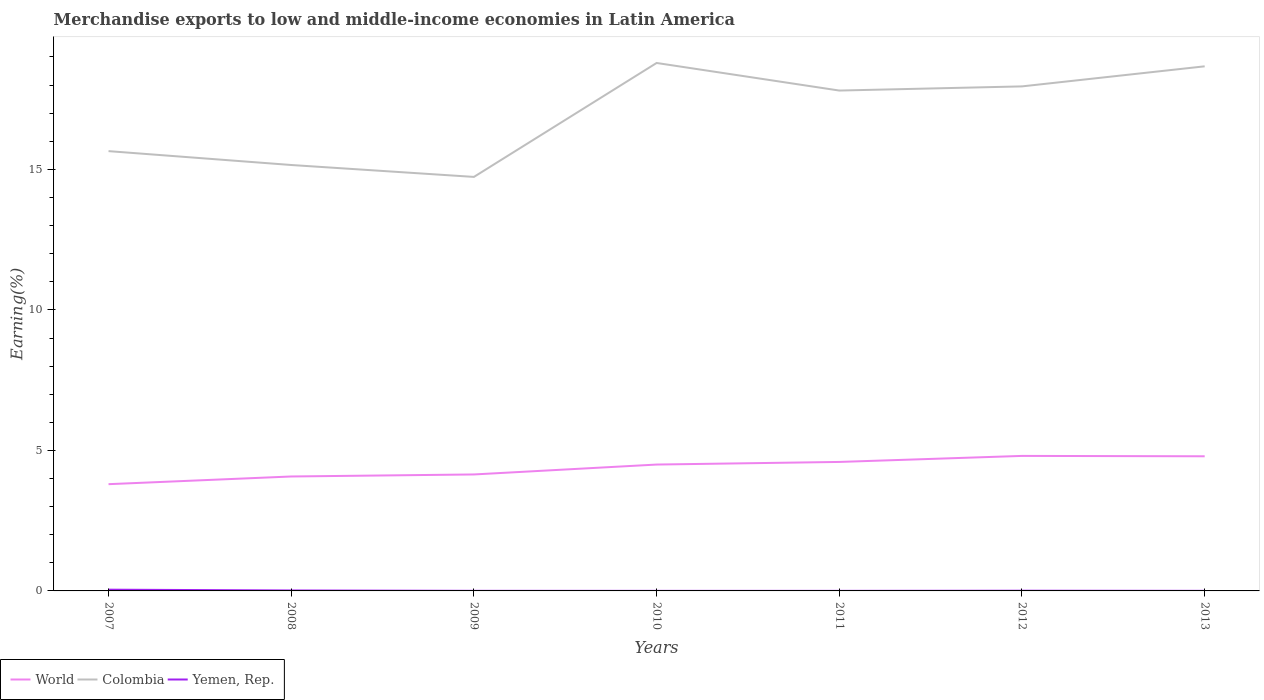Across all years, what is the maximum percentage of amount earned from merchandise exports in Yemen, Rep.?
Offer a very short reply. 0. What is the total percentage of amount earned from merchandise exports in Yemen, Rep. in the graph?
Your answer should be very brief. 0. What is the difference between the highest and the second highest percentage of amount earned from merchandise exports in World?
Your answer should be very brief. 1.01. What is the difference between the highest and the lowest percentage of amount earned from merchandise exports in World?
Make the answer very short. 4. Is the percentage of amount earned from merchandise exports in World strictly greater than the percentage of amount earned from merchandise exports in Colombia over the years?
Ensure brevity in your answer.  Yes. How many years are there in the graph?
Make the answer very short. 7. What is the difference between two consecutive major ticks on the Y-axis?
Offer a very short reply. 5. Does the graph contain any zero values?
Keep it short and to the point. No. How many legend labels are there?
Offer a very short reply. 3. How are the legend labels stacked?
Offer a terse response. Horizontal. What is the title of the graph?
Your answer should be compact. Merchandise exports to low and middle-income economies in Latin America. What is the label or title of the X-axis?
Keep it short and to the point. Years. What is the label or title of the Y-axis?
Your answer should be compact. Earning(%). What is the Earning(%) of World in 2007?
Give a very brief answer. 3.8. What is the Earning(%) of Colombia in 2007?
Provide a succinct answer. 15.65. What is the Earning(%) of Yemen, Rep. in 2007?
Offer a terse response. 0.04. What is the Earning(%) in World in 2008?
Keep it short and to the point. 4.07. What is the Earning(%) in Colombia in 2008?
Provide a short and direct response. 15.16. What is the Earning(%) of Yemen, Rep. in 2008?
Offer a very short reply. 0.02. What is the Earning(%) in World in 2009?
Offer a very short reply. 4.14. What is the Earning(%) of Colombia in 2009?
Provide a short and direct response. 14.73. What is the Earning(%) in Yemen, Rep. in 2009?
Provide a succinct answer. 0. What is the Earning(%) of World in 2010?
Make the answer very short. 4.5. What is the Earning(%) in Colombia in 2010?
Provide a short and direct response. 18.79. What is the Earning(%) of Yemen, Rep. in 2010?
Your answer should be very brief. 0. What is the Earning(%) in World in 2011?
Provide a succinct answer. 4.59. What is the Earning(%) in Colombia in 2011?
Your answer should be very brief. 17.81. What is the Earning(%) of Yemen, Rep. in 2011?
Ensure brevity in your answer.  0. What is the Earning(%) of World in 2012?
Your answer should be compact. 4.8. What is the Earning(%) in Colombia in 2012?
Keep it short and to the point. 17.95. What is the Earning(%) in Yemen, Rep. in 2012?
Offer a terse response. 0.01. What is the Earning(%) in World in 2013?
Your response must be concise. 4.79. What is the Earning(%) of Colombia in 2013?
Ensure brevity in your answer.  18.67. What is the Earning(%) in Yemen, Rep. in 2013?
Keep it short and to the point. 0. Across all years, what is the maximum Earning(%) in World?
Make the answer very short. 4.8. Across all years, what is the maximum Earning(%) in Colombia?
Ensure brevity in your answer.  18.79. Across all years, what is the maximum Earning(%) of Yemen, Rep.?
Your answer should be compact. 0.04. Across all years, what is the minimum Earning(%) of World?
Offer a terse response. 3.8. Across all years, what is the minimum Earning(%) in Colombia?
Your answer should be very brief. 14.73. Across all years, what is the minimum Earning(%) of Yemen, Rep.?
Provide a short and direct response. 0. What is the total Earning(%) in World in the graph?
Offer a very short reply. 30.7. What is the total Earning(%) of Colombia in the graph?
Provide a succinct answer. 118.76. What is the total Earning(%) of Yemen, Rep. in the graph?
Provide a succinct answer. 0.08. What is the difference between the Earning(%) of World in 2007 and that in 2008?
Offer a very short reply. -0.27. What is the difference between the Earning(%) in Colombia in 2007 and that in 2008?
Give a very brief answer. 0.49. What is the difference between the Earning(%) in Yemen, Rep. in 2007 and that in 2008?
Ensure brevity in your answer.  0.03. What is the difference between the Earning(%) of World in 2007 and that in 2009?
Ensure brevity in your answer.  -0.35. What is the difference between the Earning(%) of Colombia in 2007 and that in 2009?
Give a very brief answer. 0.92. What is the difference between the Earning(%) of Yemen, Rep. in 2007 and that in 2009?
Your response must be concise. 0.04. What is the difference between the Earning(%) in World in 2007 and that in 2010?
Your answer should be compact. -0.7. What is the difference between the Earning(%) of Colombia in 2007 and that in 2010?
Ensure brevity in your answer.  -3.14. What is the difference between the Earning(%) in Yemen, Rep. in 2007 and that in 2010?
Your answer should be compact. 0.04. What is the difference between the Earning(%) of World in 2007 and that in 2011?
Ensure brevity in your answer.  -0.79. What is the difference between the Earning(%) in Colombia in 2007 and that in 2011?
Your answer should be compact. -2.16. What is the difference between the Earning(%) in Yemen, Rep. in 2007 and that in 2011?
Your answer should be compact. 0.04. What is the difference between the Earning(%) of World in 2007 and that in 2012?
Your response must be concise. -1.01. What is the difference between the Earning(%) in Colombia in 2007 and that in 2012?
Provide a succinct answer. -2.3. What is the difference between the Earning(%) of Yemen, Rep. in 2007 and that in 2012?
Your answer should be compact. 0.04. What is the difference between the Earning(%) of World in 2007 and that in 2013?
Make the answer very short. -0.99. What is the difference between the Earning(%) of Colombia in 2007 and that in 2013?
Your answer should be very brief. -3.02. What is the difference between the Earning(%) of Yemen, Rep. in 2007 and that in 2013?
Provide a succinct answer. 0.04. What is the difference between the Earning(%) in World in 2008 and that in 2009?
Your answer should be very brief. -0.07. What is the difference between the Earning(%) in Colombia in 2008 and that in 2009?
Make the answer very short. 0.42. What is the difference between the Earning(%) in Yemen, Rep. in 2008 and that in 2009?
Provide a succinct answer. 0.01. What is the difference between the Earning(%) of World in 2008 and that in 2010?
Offer a terse response. -0.42. What is the difference between the Earning(%) of Colombia in 2008 and that in 2010?
Your answer should be compact. -3.63. What is the difference between the Earning(%) of Yemen, Rep. in 2008 and that in 2010?
Give a very brief answer. 0.01. What is the difference between the Earning(%) of World in 2008 and that in 2011?
Keep it short and to the point. -0.52. What is the difference between the Earning(%) of Colombia in 2008 and that in 2011?
Provide a short and direct response. -2.65. What is the difference between the Earning(%) in Yemen, Rep. in 2008 and that in 2011?
Your response must be concise. 0.01. What is the difference between the Earning(%) of World in 2008 and that in 2012?
Make the answer very short. -0.73. What is the difference between the Earning(%) in Colombia in 2008 and that in 2012?
Offer a terse response. -2.8. What is the difference between the Earning(%) in Yemen, Rep. in 2008 and that in 2012?
Offer a terse response. 0.01. What is the difference between the Earning(%) of World in 2008 and that in 2013?
Your answer should be very brief. -0.72. What is the difference between the Earning(%) of Colombia in 2008 and that in 2013?
Give a very brief answer. -3.51. What is the difference between the Earning(%) of Yemen, Rep. in 2008 and that in 2013?
Provide a short and direct response. 0.01. What is the difference between the Earning(%) of World in 2009 and that in 2010?
Provide a succinct answer. -0.35. What is the difference between the Earning(%) of Colombia in 2009 and that in 2010?
Your answer should be compact. -4.05. What is the difference between the Earning(%) of Yemen, Rep. in 2009 and that in 2010?
Your answer should be compact. 0. What is the difference between the Earning(%) of World in 2009 and that in 2011?
Give a very brief answer. -0.45. What is the difference between the Earning(%) in Colombia in 2009 and that in 2011?
Offer a terse response. -3.07. What is the difference between the Earning(%) of Yemen, Rep. in 2009 and that in 2011?
Your answer should be very brief. 0. What is the difference between the Earning(%) in World in 2009 and that in 2012?
Your response must be concise. -0.66. What is the difference between the Earning(%) of Colombia in 2009 and that in 2012?
Keep it short and to the point. -3.22. What is the difference between the Earning(%) in Yemen, Rep. in 2009 and that in 2012?
Offer a very short reply. -0. What is the difference between the Earning(%) in World in 2009 and that in 2013?
Give a very brief answer. -0.65. What is the difference between the Earning(%) of Colombia in 2009 and that in 2013?
Offer a terse response. -3.94. What is the difference between the Earning(%) in World in 2010 and that in 2011?
Your answer should be very brief. -0.09. What is the difference between the Earning(%) in Colombia in 2010 and that in 2011?
Ensure brevity in your answer.  0.98. What is the difference between the Earning(%) of World in 2010 and that in 2012?
Provide a succinct answer. -0.31. What is the difference between the Earning(%) of Colombia in 2010 and that in 2012?
Your response must be concise. 0.83. What is the difference between the Earning(%) in Yemen, Rep. in 2010 and that in 2012?
Give a very brief answer. -0.01. What is the difference between the Earning(%) of World in 2010 and that in 2013?
Offer a very short reply. -0.29. What is the difference between the Earning(%) of Colombia in 2010 and that in 2013?
Give a very brief answer. 0.12. What is the difference between the Earning(%) in Yemen, Rep. in 2010 and that in 2013?
Your answer should be compact. -0. What is the difference between the Earning(%) of World in 2011 and that in 2012?
Make the answer very short. -0.21. What is the difference between the Earning(%) of Colombia in 2011 and that in 2012?
Your answer should be compact. -0.15. What is the difference between the Earning(%) of Yemen, Rep. in 2011 and that in 2012?
Offer a very short reply. -0.01. What is the difference between the Earning(%) of World in 2011 and that in 2013?
Provide a short and direct response. -0.2. What is the difference between the Earning(%) in Colombia in 2011 and that in 2013?
Keep it short and to the point. -0.86. What is the difference between the Earning(%) of Yemen, Rep. in 2011 and that in 2013?
Provide a succinct answer. -0. What is the difference between the Earning(%) of World in 2012 and that in 2013?
Offer a very short reply. 0.01. What is the difference between the Earning(%) in Colombia in 2012 and that in 2013?
Offer a terse response. -0.71. What is the difference between the Earning(%) in Yemen, Rep. in 2012 and that in 2013?
Give a very brief answer. 0. What is the difference between the Earning(%) in World in 2007 and the Earning(%) in Colombia in 2008?
Your answer should be compact. -11.36. What is the difference between the Earning(%) in World in 2007 and the Earning(%) in Yemen, Rep. in 2008?
Provide a short and direct response. 3.78. What is the difference between the Earning(%) in Colombia in 2007 and the Earning(%) in Yemen, Rep. in 2008?
Your response must be concise. 15.63. What is the difference between the Earning(%) of World in 2007 and the Earning(%) of Colombia in 2009?
Your answer should be very brief. -10.93. What is the difference between the Earning(%) of World in 2007 and the Earning(%) of Yemen, Rep. in 2009?
Provide a short and direct response. 3.8. What is the difference between the Earning(%) of Colombia in 2007 and the Earning(%) of Yemen, Rep. in 2009?
Provide a short and direct response. 15.65. What is the difference between the Earning(%) of World in 2007 and the Earning(%) of Colombia in 2010?
Keep it short and to the point. -14.99. What is the difference between the Earning(%) of World in 2007 and the Earning(%) of Yemen, Rep. in 2010?
Offer a terse response. 3.8. What is the difference between the Earning(%) in Colombia in 2007 and the Earning(%) in Yemen, Rep. in 2010?
Keep it short and to the point. 15.65. What is the difference between the Earning(%) of World in 2007 and the Earning(%) of Colombia in 2011?
Make the answer very short. -14.01. What is the difference between the Earning(%) of World in 2007 and the Earning(%) of Yemen, Rep. in 2011?
Your answer should be very brief. 3.8. What is the difference between the Earning(%) in Colombia in 2007 and the Earning(%) in Yemen, Rep. in 2011?
Provide a succinct answer. 15.65. What is the difference between the Earning(%) in World in 2007 and the Earning(%) in Colombia in 2012?
Ensure brevity in your answer.  -14.16. What is the difference between the Earning(%) in World in 2007 and the Earning(%) in Yemen, Rep. in 2012?
Your answer should be very brief. 3.79. What is the difference between the Earning(%) of Colombia in 2007 and the Earning(%) of Yemen, Rep. in 2012?
Your response must be concise. 15.64. What is the difference between the Earning(%) in World in 2007 and the Earning(%) in Colombia in 2013?
Offer a very short reply. -14.87. What is the difference between the Earning(%) in World in 2007 and the Earning(%) in Yemen, Rep. in 2013?
Your answer should be compact. 3.8. What is the difference between the Earning(%) of Colombia in 2007 and the Earning(%) of Yemen, Rep. in 2013?
Offer a terse response. 15.65. What is the difference between the Earning(%) of World in 2008 and the Earning(%) of Colombia in 2009?
Give a very brief answer. -10.66. What is the difference between the Earning(%) in World in 2008 and the Earning(%) in Yemen, Rep. in 2009?
Your answer should be compact. 4.07. What is the difference between the Earning(%) of Colombia in 2008 and the Earning(%) of Yemen, Rep. in 2009?
Give a very brief answer. 15.15. What is the difference between the Earning(%) of World in 2008 and the Earning(%) of Colombia in 2010?
Your response must be concise. -14.72. What is the difference between the Earning(%) in World in 2008 and the Earning(%) in Yemen, Rep. in 2010?
Your answer should be very brief. 4.07. What is the difference between the Earning(%) in Colombia in 2008 and the Earning(%) in Yemen, Rep. in 2010?
Offer a very short reply. 15.15. What is the difference between the Earning(%) in World in 2008 and the Earning(%) in Colombia in 2011?
Keep it short and to the point. -13.73. What is the difference between the Earning(%) in World in 2008 and the Earning(%) in Yemen, Rep. in 2011?
Your response must be concise. 4.07. What is the difference between the Earning(%) of Colombia in 2008 and the Earning(%) of Yemen, Rep. in 2011?
Your answer should be very brief. 15.15. What is the difference between the Earning(%) of World in 2008 and the Earning(%) of Colombia in 2012?
Ensure brevity in your answer.  -13.88. What is the difference between the Earning(%) of World in 2008 and the Earning(%) of Yemen, Rep. in 2012?
Your response must be concise. 4.06. What is the difference between the Earning(%) of Colombia in 2008 and the Earning(%) of Yemen, Rep. in 2012?
Your answer should be compact. 15.15. What is the difference between the Earning(%) in World in 2008 and the Earning(%) in Colombia in 2013?
Offer a very short reply. -14.6. What is the difference between the Earning(%) in World in 2008 and the Earning(%) in Yemen, Rep. in 2013?
Make the answer very short. 4.07. What is the difference between the Earning(%) in Colombia in 2008 and the Earning(%) in Yemen, Rep. in 2013?
Keep it short and to the point. 15.15. What is the difference between the Earning(%) in World in 2009 and the Earning(%) in Colombia in 2010?
Ensure brevity in your answer.  -14.64. What is the difference between the Earning(%) in World in 2009 and the Earning(%) in Yemen, Rep. in 2010?
Make the answer very short. 4.14. What is the difference between the Earning(%) in Colombia in 2009 and the Earning(%) in Yemen, Rep. in 2010?
Your answer should be compact. 14.73. What is the difference between the Earning(%) in World in 2009 and the Earning(%) in Colombia in 2011?
Provide a succinct answer. -13.66. What is the difference between the Earning(%) of World in 2009 and the Earning(%) of Yemen, Rep. in 2011?
Your answer should be very brief. 4.14. What is the difference between the Earning(%) of Colombia in 2009 and the Earning(%) of Yemen, Rep. in 2011?
Your response must be concise. 14.73. What is the difference between the Earning(%) in World in 2009 and the Earning(%) in Colombia in 2012?
Offer a very short reply. -13.81. What is the difference between the Earning(%) of World in 2009 and the Earning(%) of Yemen, Rep. in 2012?
Offer a terse response. 4.14. What is the difference between the Earning(%) in Colombia in 2009 and the Earning(%) in Yemen, Rep. in 2012?
Your response must be concise. 14.73. What is the difference between the Earning(%) in World in 2009 and the Earning(%) in Colombia in 2013?
Ensure brevity in your answer.  -14.52. What is the difference between the Earning(%) in World in 2009 and the Earning(%) in Yemen, Rep. in 2013?
Keep it short and to the point. 4.14. What is the difference between the Earning(%) in Colombia in 2009 and the Earning(%) in Yemen, Rep. in 2013?
Ensure brevity in your answer.  14.73. What is the difference between the Earning(%) in World in 2010 and the Earning(%) in Colombia in 2011?
Your response must be concise. -13.31. What is the difference between the Earning(%) in World in 2010 and the Earning(%) in Yemen, Rep. in 2011?
Your response must be concise. 4.49. What is the difference between the Earning(%) of Colombia in 2010 and the Earning(%) of Yemen, Rep. in 2011?
Offer a very short reply. 18.79. What is the difference between the Earning(%) of World in 2010 and the Earning(%) of Colombia in 2012?
Provide a short and direct response. -13.46. What is the difference between the Earning(%) of World in 2010 and the Earning(%) of Yemen, Rep. in 2012?
Your response must be concise. 4.49. What is the difference between the Earning(%) in Colombia in 2010 and the Earning(%) in Yemen, Rep. in 2012?
Offer a very short reply. 18.78. What is the difference between the Earning(%) in World in 2010 and the Earning(%) in Colombia in 2013?
Make the answer very short. -14.17. What is the difference between the Earning(%) of World in 2010 and the Earning(%) of Yemen, Rep. in 2013?
Provide a succinct answer. 4.49. What is the difference between the Earning(%) in Colombia in 2010 and the Earning(%) in Yemen, Rep. in 2013?
Offer a terse response. 18.78. What is the difference between the Earning(%) in World in 2011 and the Earning(%) in Colombia in 2012?
Provide a succinct answer. -13.36. What is the difference between the Earning(%) of World in 2011 and the Earning(%) of Yemen, Rep. in 2012?
Provide a short and direct response. 4.58. What is the difference between the Earning(%) in Colombia in 2011 and the Earning(%) in Yemen, Rep. in 2012?
Ensure brevity in your answer.  17.8. What is the difference between the Earning(%) in World in 2011 and the Earning(%) in Colombia in 2013?
Your answer should be compact. -14.08. What is the difference between the Earning(%) in World in 2011 and the Earning(%) in Yemen, Rep. in 2013?
Make the answer very short. 4.59. What is the difference between the Earning(%) in Colombia in 2011 and the Earning(%) in Yemen, Rep. in 2013?
Offer a terse response. 17.8. What is the difference between the Earning(%) of World in 2012 and the Earning(%) of Colombia in 2013?
Keep it short and to the point. -13.86. What is the difference between the Earning(%) of World in 2012 and the Earning(%) of Yemen, Rep. in 2013?
Provide a succinct answer. 4.8. What is the difference between the Earning(%) in Colombia in 2012 and the Earning(%) in Yemen, Rep. in 2013?
Give a very brief answer. 17.95. What is the average Earning(%) in World per year?
Offer a terse response. 4.39. What is the average Earning(%) in Colombia per year?
Give a very brief answer. 16.97. What is the average Earning(%) of Yemen, Rep. per year?
Your response must be concise. 0.01. In the year 2007, what is the difference between the Earning(%) of World and Earning(%) of Colombia?
Provide a short and direct response. -11.85. In the year 2007, what is the difference between the Earning(%) of World and Earning(%) of Yemen, Rep.?
Your answer should be very brief. 3.75. In the year 2007, what is the difference between the Earning(%) of Colombia and Earning(%) of Yemen, Rep.?
Offer a terse response. 15.61. In the year 2008, what is the difference between the Earning(%) of World and Earning(%) of Colombia?
Keep it short and to the point. -11.08. In the year 2008, what is the difference between the Earning(%) in World and Earning(%) in Yemen, Rep.?
Make the answer very short. 4.06. In the year 2008, what is the difference between the Earning(%) of Colombia and Earning(%) of Yemen, Rep.?
Make the answer very short. 15.14. In the year 2009, what is the difference between the Earning(%) in World and Earning(%) in Colombia?
Give a very brief answer. -10.59. In the year 2009, what is the difference between the Earning(%) of World and Earning(%) of Yemen, Rep.?
Your answer should be very brief. 4.14. In the year 2009, what is the difference between the Earning(%) of Colombia and Earning(%) of Yemen, Rep.?
Offer a terse response. 14.73. In the year 2010, what is the difference between the Earning(%) in World and Earning(%) in Colombia?
Provide a short and direct response. -14.29. In the year 2010, what is the difference between the Earning(%) of World and Earning(%) of Yemen, Rep.?
Provide a succinct answer. 4.49. In the year 2010, what is the difference between the Earning(%) of Colombia and Earning(%) of Yemen, Rep.?
Your answer should be compact. 18.79. In the year 2011, what is the difference between the Earning(%) of World and Earning(%) of Colombia?
Your answer should be very brief. -13.22. In the year 2011, what is the difference between the Earning(%) of World and Earning(%) of Yemen, Rep.?
Make the answer very short. 4.59. In the year 2011, what is the difference between the Earning(%) of Colombia and Earning(%) of Yemen, Rep.?
Provide a succinct answer. 17.8. In the year 2012, what is the difference between the Earning(%) of World and Earning(%) of Colombia?
Offer a terse response. -13.15. In the year 2012, what is the difference between the Earning(%) in World and Earning(%) in Yemen, Rep.?
Offer a terse response. 4.8. In the year 2012, what is the difference between the Earning(%) of Colombia and Earning(%) of Yemen, Rep.?
Keep it short and to the point. 17.95. In the year 2013, what is the difference between the Earning(%) in World and Earning(%) in Colombia?
Your answer should be very brief. -13.88. In the year 2013, what is the difference between the Earning(%) of World and Earning(%) of Yemen, Rep.?
Give a very brief answer. 4.79. In the year 2013, what is the difference between the Earning(%) of Colombia and Earning(%) of Yemen, Rep.?
Your answer should be very brief. 18.67. What is the ratio of the Earning(%) in World in 2007 to that in 2008?
Your answer should be very brief. 0.93. What is the ratio of the Earning(%) of Colombia in 2007 to that in 2008?
Give a very brief answer. 1.03. What is the ratio of the Earning(%) of Yemen, Rep. in 2007 to that in 2008?
Keep it short and to the point. 2.81. What is the ratio of the Earning(%) in World in 2007 to that in 2009?
Provide a short and direct response. 0.92. What is the ratio of the Earning(%) of Colombia in 2007 to that in 2009?
Your answer should be very brief. 1.06. What is the ratio of the Earning(%) in Yemen, Rep. in 2007 to that in 2009?
Give a very brief answer. 14.2. What is the ratio of the Earning(%) of World in 2007 to that in 2010?
Give a very brief answer. 0.84. What is the ratio of the Earning(%) in Colombia in 2007 to that in 2010?
Make the answer very short. 0.83. What is the ratio of the Earning(%) of Yemen, Rep. in 2007 to that in 2010?
Provide a short and direct response. 20.21. What is the ratio of the Earning(%) in World in 2007 to that in 2011?
Provide a succinct answer. 0.83. What is the ratio of the Earning(%) of Colombia in 2007 to that in 2011?
Your response must be concise. 0.88. What is the ratio of the Earning(%) of Yemen, Rep. in 2007 to that in 2011?
Keep it short and to the point. 19.93. What is the ratio of the Earning(%) of World in 2007 to that in 2012?
Keep it short and to the point. 0.79. What is the ratio of the Earning(%) in Colombia in 2007 to that in 2012?
Make the answer very short. 0.87. What is the ratio of the Earning(%) of Yemen, Rep. in 2007 to that in 2012?
Give a very brief answer. 6.05. What is the ratio of the Earning(%) of World in 2007 to that in 2013?
Offer a very short reply. 0.79. What is the ratio of the Earning(%) of Colombia in 2007 to that in 2013?
Provide a succinct answer. 0.84. What is the ratio of the Earning(%) in Yemen, Rep. in 2007 to that in 2013?
Keep it short and to the point. 16.91. What is the ratio of the Earning(%) of World in 2008 to that in 2009?
Your answer should be very brief. 0.98. What is the ratio of the Earning(%) of Colombia in 2008 to that in 2009?
Your answer should be compact. 1.03. What is the ratio of the Earning(%) in Yemen, Rep. in 2008 to that in 2009?
Provide a succinct answer. 5.05. What is the ratio of the Earning(%) of World in 2008 to that in 2010?
Provide a short and direct response. 0.91. What is the ratio of the Earning(%) in Colombia in 2008 to that in 2010?
Your answer should be compact. 0.81. What is the ratio of the Earning(%) in Yemen, Rep. in 2008 to that in 2010?
Provide a short and direct response. 7.18. What is the ratio of the Earning(%) of World in 2008 to that in 2011?
Your answer should be compact. 0.89. What is the ratio of the Earning(%) in Colombia in 2008 to that in 2011?
Provide a short and direct response. 0.85. What is the ratio of the Earning(%) of Yemen, Rep. in 2008 to that in 2011?
Your answer should be compact. 7.08. What is the ratio of the Earning(%) of World in 2008 to that in 2012?
Offer a terse response. 0.85. What is the ratio of the Earning(%) in Colombia in 2008 to that in 2012?
Your answer should be very brief. 0.84. What is the ratio of the Earning(%) of Yemen, Rep. in 2008 to that in 2012?
Provide a succinct answer. 2.15. What is the ratio of the Earning(%) in World in 2008 to that in 2013?
Your response must be concise. 0.85. What is the ratio of the Earning(%) of Colombia in 2008 to that in 2013?
Your response must be concise. 0.81. What is the ratio of the Earning(%) in Yemen, Rep. in 2008 to that in 2013?
Provide a succinct answer. 6.01. What is the ratio of the Earning(%) in World in 2009 to that in 2010?
Give a very brief answer. 0.92. What is the ratio of the Earning(%) in Colombia in 2009 to that in 2010?
Offer a terse response. 0.78. What is the ratio of the Earning(%) in Yemen, Rep. in 2009 to that in 2010?
Your answer should be very brief. 1.42. What is the ratio of the Earning(%) in World in 2009 to that in 2011?
Offer a terse response. 0.9. What is the ratio of the Earning(%) in Colombia in 2009 to that in 2011?
Make the answer very short. 0.83. What is the ratio of the Earning(%) of Yemen, Rep. in 2009 to that in 2011?
Your response must be concise. 1.4. What is the ratio of the Earning(%) in World in 2009 to that in 2012?
Give a very brief answer. 0.86. What is the ratio of the Earning(%) in Colombia in 2009 to that in 2012?
Your answer should be compact. 0.82. What is the ratio of the Earning(%) in Yemen, Rep. in 2009 to that in 2012?
Offer a very short reply. 0.43. What is the ratio of the Earning(%) of World in 2009 to that in 2013?
Your answer should be compact. 0.86. What is the ratio of the Earning(%) in Colombia in 2009 to that in 2013?
Ensure brevity in your answer.  0.79. What is the ratio of the Earning(%) in Yemen, Rep. in 2009 to that in 2013?
Give a very brief answer. 1.19. What is the ratio of the Earning(%) of World in 2010 to that in 2011?
Your response must be concise. 0.98. What is the ratio of the Earning(%) of Colombia in 2010 to that in 2011?
Your answer should be compact. 1.06. What is the ratio of the Earning(%) of World in 2010 to that in 2012?
Give a very brief answer. 0.94. What is the ratio of the Earning(%) in Colombia in 2010 to that in 2012?
Offer a terse response. 1.05. What is the ratio of the Earning(%) in Yemen, Rep. in 2010 to that in 2012?
Your answer should be very brief. 0.3. What is the ratio of the Earning(%) of World in 2010 to that in 2013?
Give a very brief answer. 0.94. What is the ratio of the Earning(%) in Colombia in 2010 to that in 2013?
Offer a terse response. 1.01. What is the ratio of the Earning(%) of Yemen, Rep. in 2010 to that in 2013?
Keep it short and to the point. 0.84. What is the ratio of the Earning(%) in World in 2011 to that in 2012?
Offer a terse response. 0.96. What is the ratio of the Earning(%) of Colombia in 2011 to that in 2012?
Keep it short and to the point. 0.99. What is the ratio of the Earning(%) in Yemen, Rep. in 2011 to that in 2012?
Provide a succinct answer. 0.3. What is the ratio of the Earning(%) of World in 2011 to that in 2013?
Your answer should be very brief. 0.96. What is the ratio of the Earning(%) in Colombia in 2011 to that in 2013?
Your response must be concise. 0.95. What is the ratio of the Earning(%) of Yemen, Rep. in 2011 to that in 2013?
Provide a succinct answer. 0.85. What is the ratio of the Earning(%) of Colombia in 2012 to that in 2013?
Make the answer very short. 0.96. What is the ratio of the Earning(%) of Yemen, Rep. in 2012 to that in 2013?
Keep it short and to the point. 2.8. What is the difference between the highest and the second highest Earning(%) of World?
Keep it short and to the point. 0.01. What is the difference between the highest and the second highest Earning(%) in Colombia?
Offer a very short reply. 0.12. What is the difference between the highest and the second highest Earning(%) of Yemen, Rep.?
Offer a very short reply. 0.03. What is the difference between the highest and the lowest Earning(%) of World?
Provide a short and direct response. 1.01. What is the difference between the highest and the lowest Earning(%) of Colombia?
Your answer should be compact. 4.05. What is the difference between the highest and the lowest Earning(%) in Yemen, Rep.?
Provide a short and direct response. 0.04. 